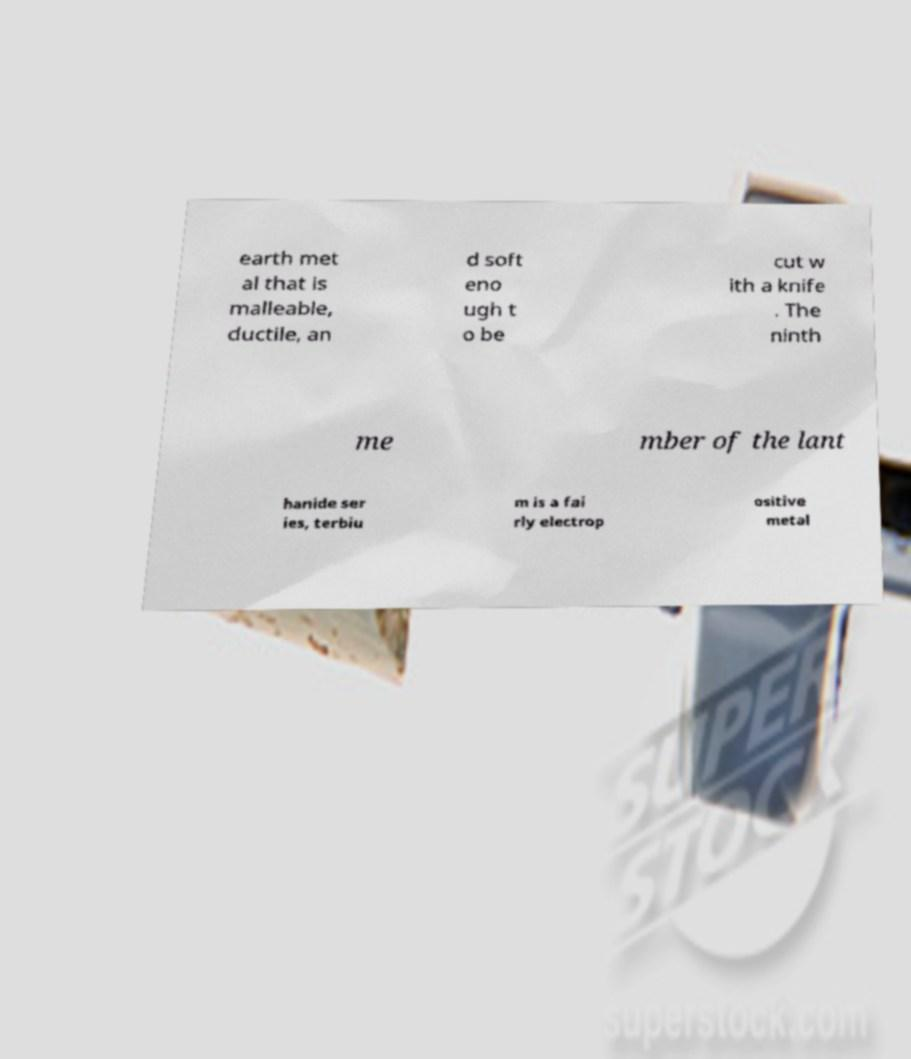Could you assist in decoding the text presented in this image and type it out clearly? earth met al that is malleable, ductile, an d soft eno ugh t o be cut w ith a knife . The ninth me mber of the lant hanide ser ies, terbiu m is a fai rly electrop ositive metal 